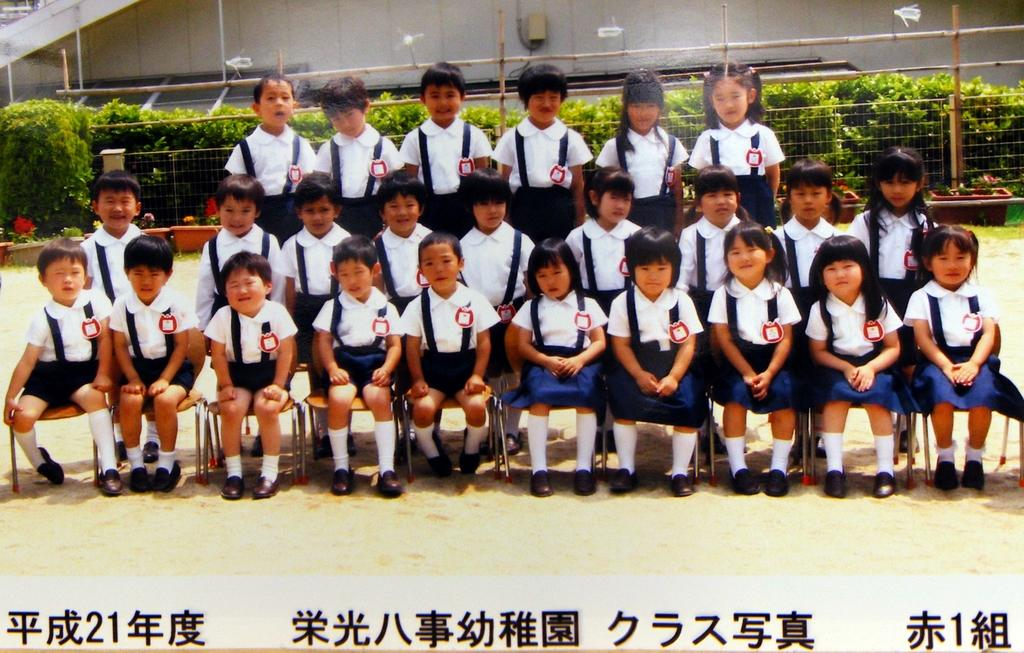What is happening in the foreground of the picture? There are boys and girls in the foreground of the picture, and they are sitting on chairs. What are the boys and girls doing in the picture? They are posing for a camera. What can be seen in the background of the image? There are plants, a railing, sticks, sand, and a wall in the background. What color is the brass in the image? There is no brass present in the image. How many elbows can be seen in the image? The number of elbows cannot be determined from the image, as it only shows the boys and girls sitting on chairs and posing for a camera. 